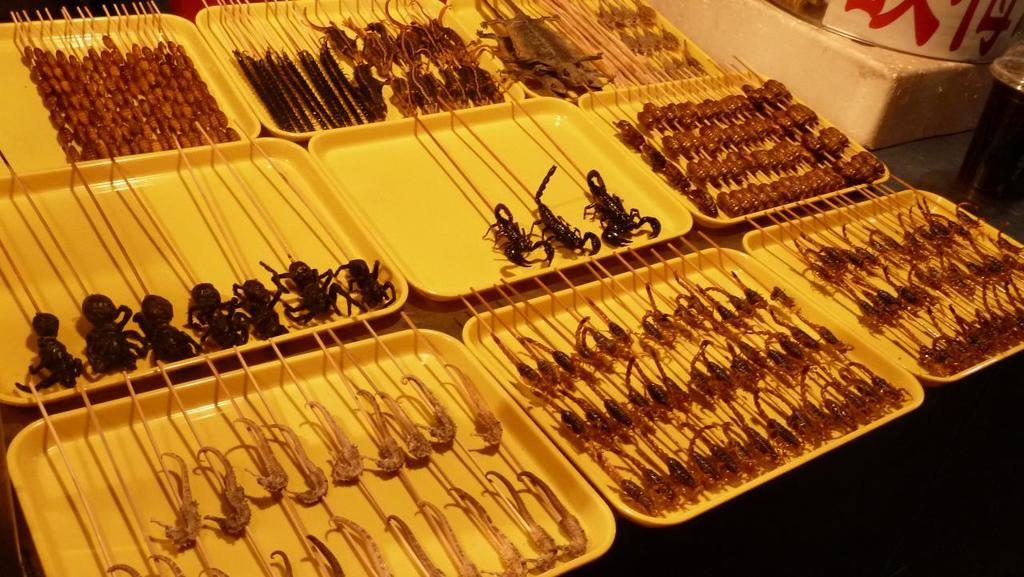What type of animals are in the image? There are reptiles in the image. What are the reptiles holding in their hands? The reptiles are holding sticks. What are the reptiles placed on? The reptiles are on yellow trays. What can be seen on the right side of the trays? There are objects on the right side of the trays. What is the size of the clover in the image? There is no clover present in the image. 